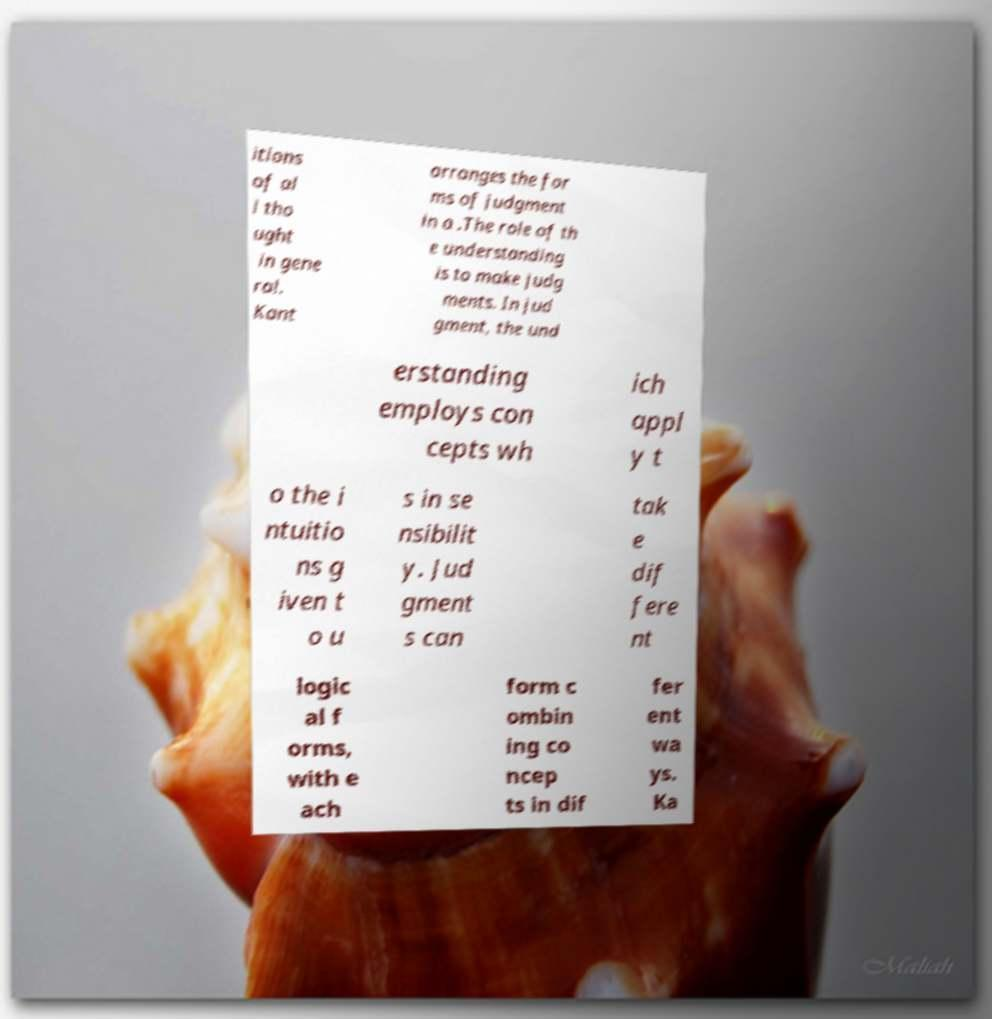I need the written content from this picture converted into text. Can you do that? itions of al l tho ught in gene ral. Kant arranges the for ms of judgment in a .The role of th e understanding is to make judg ments. In jud gment, the und erstanding employs con cepts wh ich appl y t o the i ntuitio ns g iven t o u s in se nsibilit y. Jud gment s can tak e dif fere nt logic al f orms, with e ach form c ombin ing co ncep ts in dif fer ent wa ys. Ka 